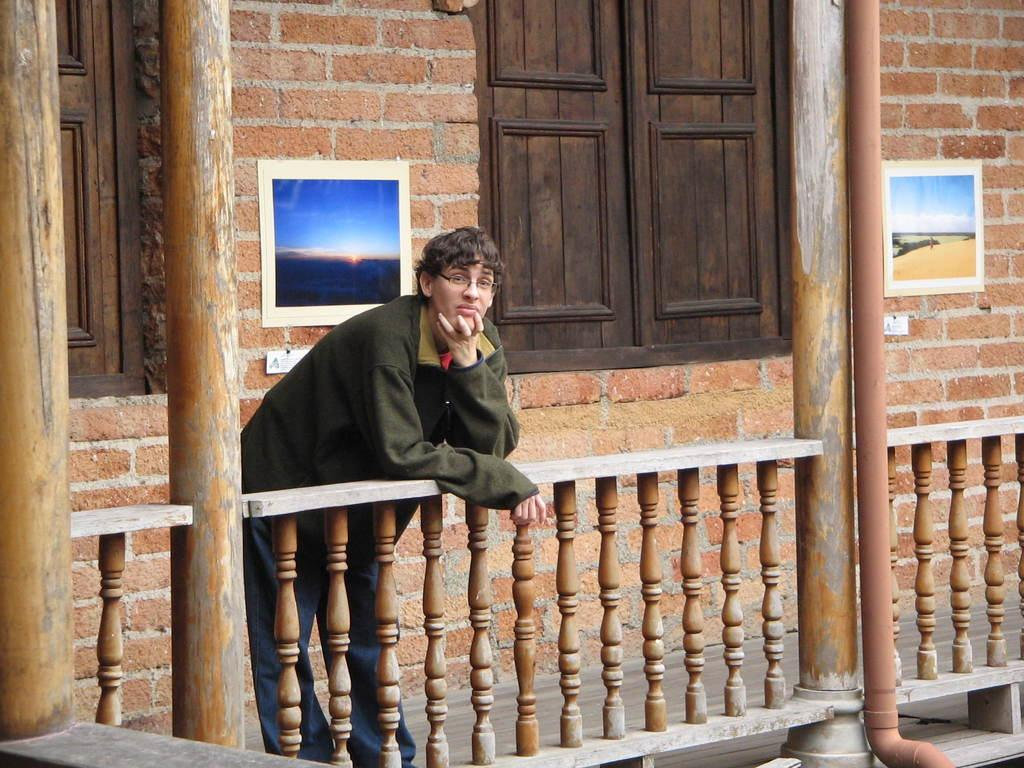What is the person in the foreground of the image doing? The person is standing on a fence in the foreground of the image. What can be seen in the background of the image? There is a wall, windows, wall paintings, and pillars visible in the background of the image. What time of day was the image taken? The image was taken during the day. What type of cave can be seen in the background of the image? There is no cave present in the image; it features a wall, windows, wall paintings, and pillars in the background. How many lizards are visible on the person's shoulder in the image? There are no lizards visible in the image; the person is standing on a fence without any lizards present. 